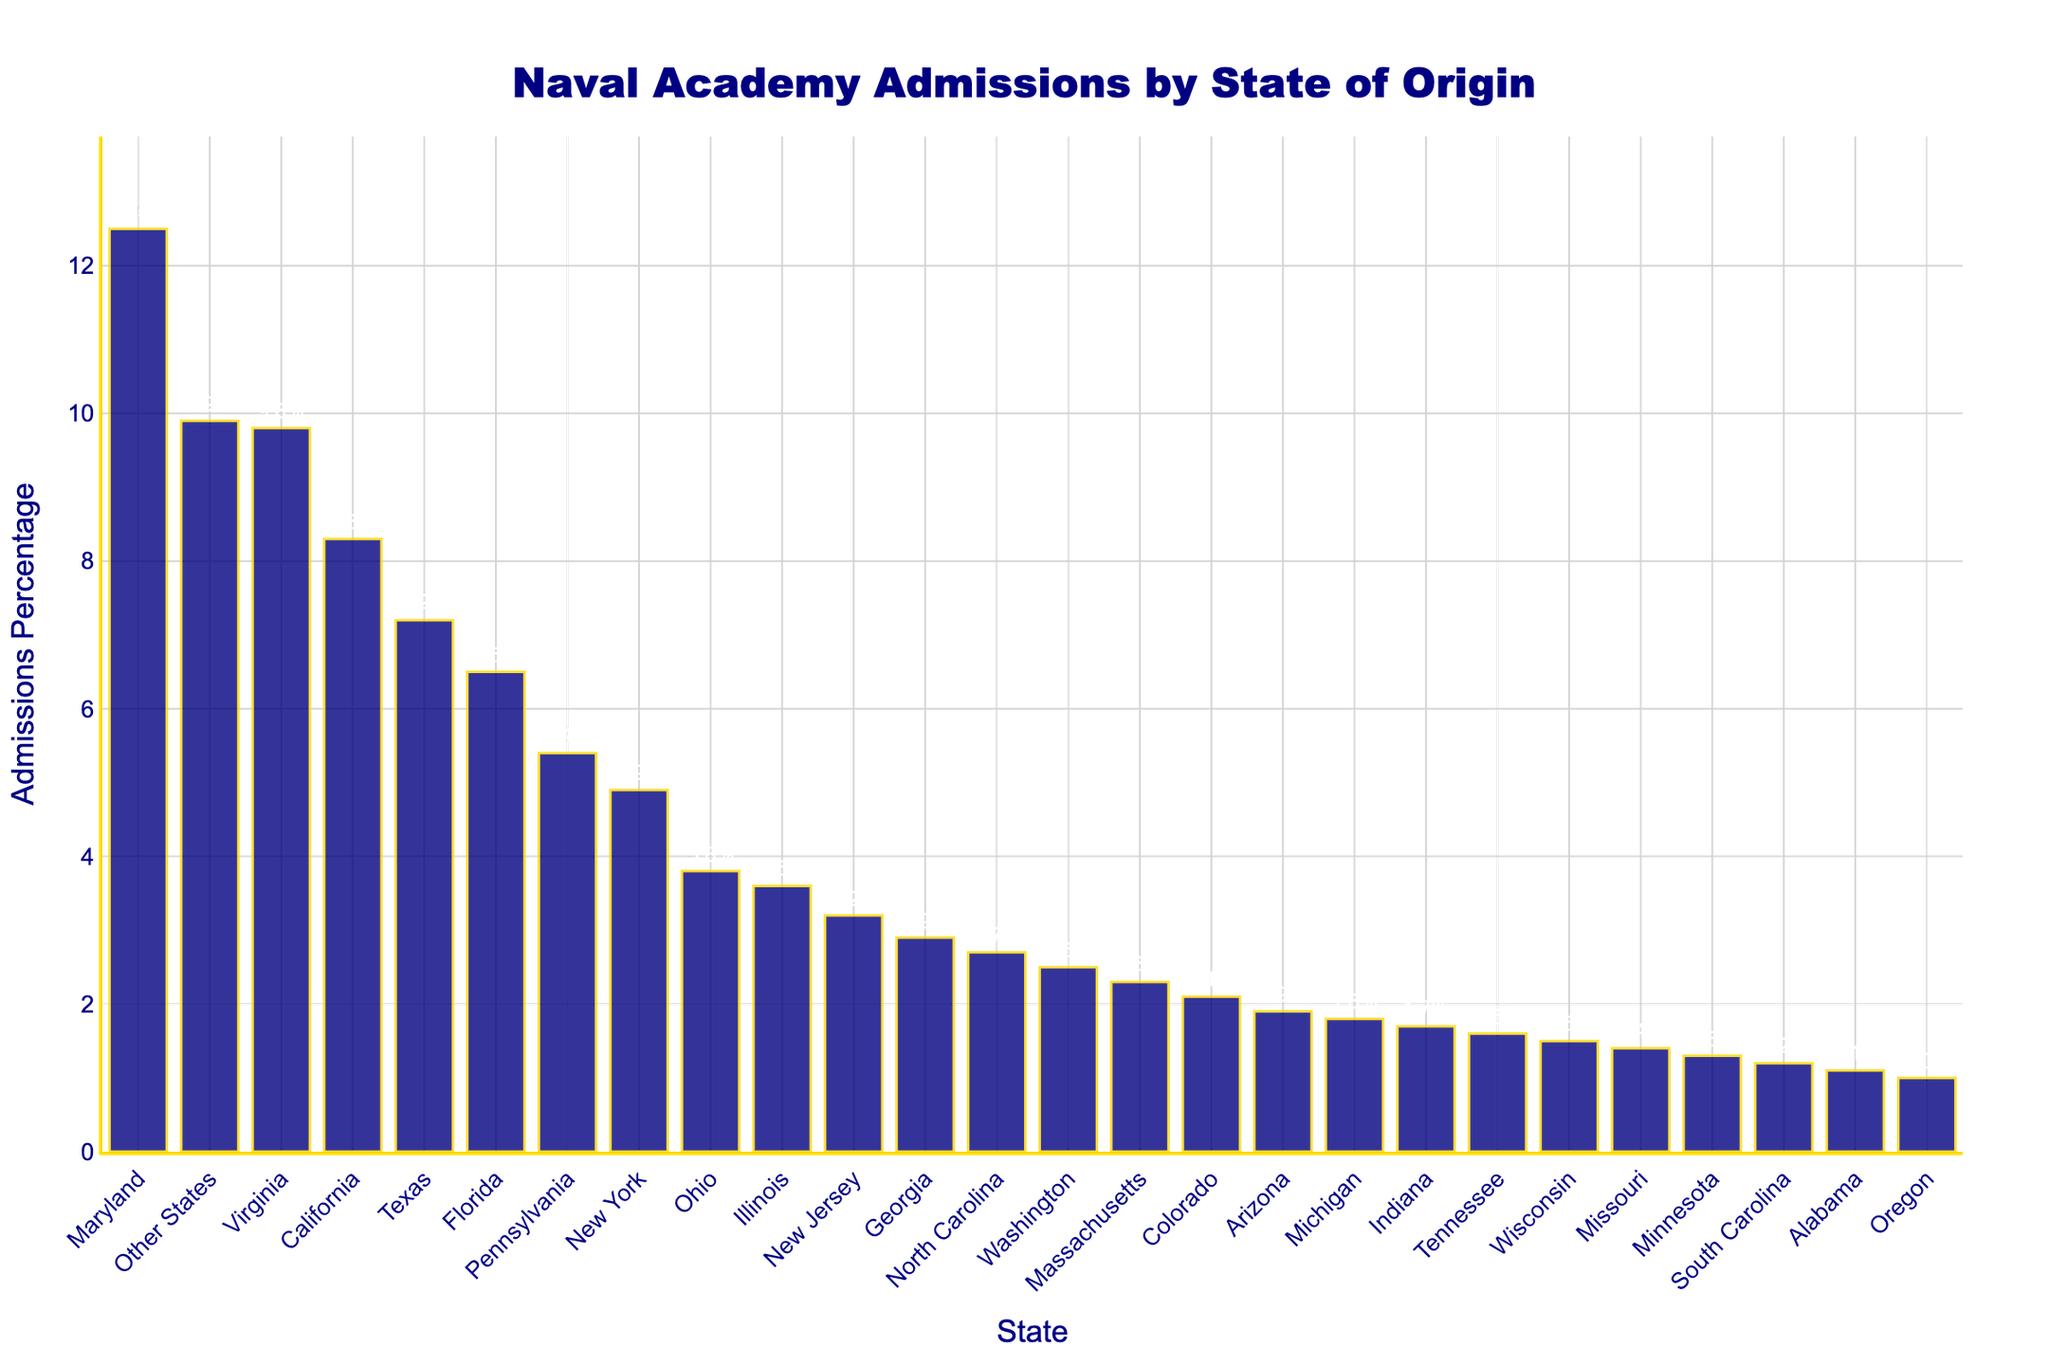What state has the highest percentage of admissions? The bar with the highest height and value label represents the state with the highest admissions percentage. Maryland's bar is the tallest at 12.5%.
Answer: Maryland How much higher is Maryland's admission percentage compared to Virginia's? Subtract Virginia's percentage (9.8%) from Maryland's percentage (12.5%). 12.5% - 9.8% = 2.7%.
Answer: 2.7% Which state has a lower admissions percentage, Florida or New York? Compare the heights and value labels of the bars for Florida (6.5%) and New York (4.9%). Since Florida's bar is higher, New York has the lower percentage.
Answer: New York Identify the midpoint value between the admissions percentages of Texas and Illinois. Texas has 7.2% and Illinois has 3.6%. Find the average: (7.2% + 3.6%)/2 = 5.4%.
Answer: 5.4% What is the combined admissions percentage for California, Pennsylvania, and Ohio? Sum the percentages of these states: California (8.3%), Pennsylvania (5.4%), and Ohio (3.8%). 8.3% + 5.4% + 3.8% = 17.5%.
Answer: 17.5% Which state has a higher admission percentage, North Carolina or Massachusetts? Compare the heights and value labels of the bars for North Carolina (2.7%) and Massachusetts (2.3%). North Carolina's bar is higher.
Answer: North Carolina How much is the total admissions percentage for the top three states? Sum the percentages for the top three states: Maryland (12.5%), Virginia (9.8%), and California (8.3%). 12.5% + 9.8% + 8.3% = 30.6%.
Answer: 30.6% Which state has an admissions percentage closest to 5%? Look at the bars and value labels around the 5% mark. New York has 4.9%, which is the closest to 5%.
Answer: New York What is the range of admissions percentages shown in the chart? Identify the highest percentage (Maryland, 12.5%) and the lowest (Oregon, 1.0%), then subtract the lowest from the highest. 12.5% - 1.0% = 11.5%.
Answer: 11.5% Among the states listed, which one has the smallest admissions percentage, and what is it? Find the bar with the smallest height and value label. Oregon has the smallest with 1.0%.
Answer: Oregon, 1.0% 